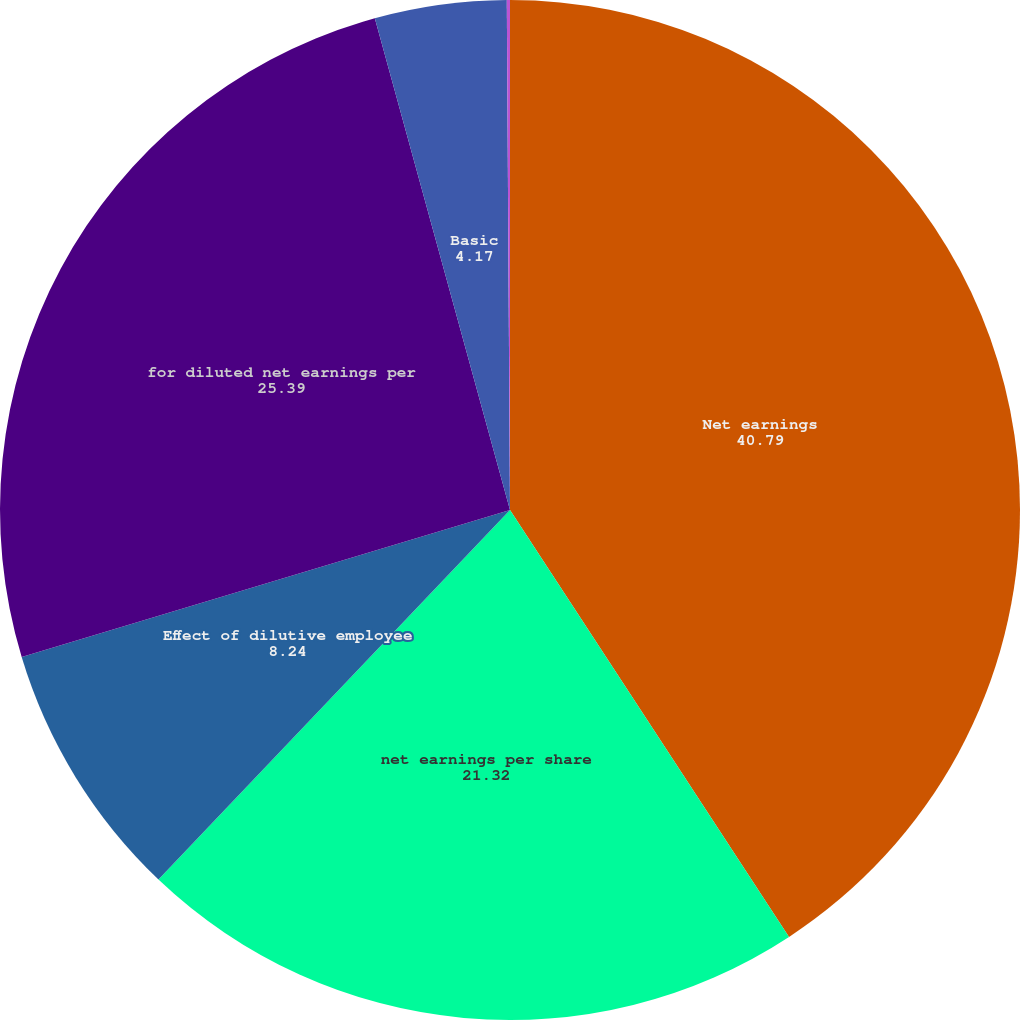Convert chart to OTSL. <chart><loc_0><loc_0><loc_500><loc_500><pie_chart><fcel>Net earnings<fcel>net earnings per share<fcel>Effect of dilutive employee<fcel>for diluted net earnings per<fcel>Basic<fcel>Diluted<nl><fcel>40.79%<fcel>21.32%<fcel>8.24%<fcel>25.39%<fcel>4.17%<fcel>0.1%<nl></chart> 